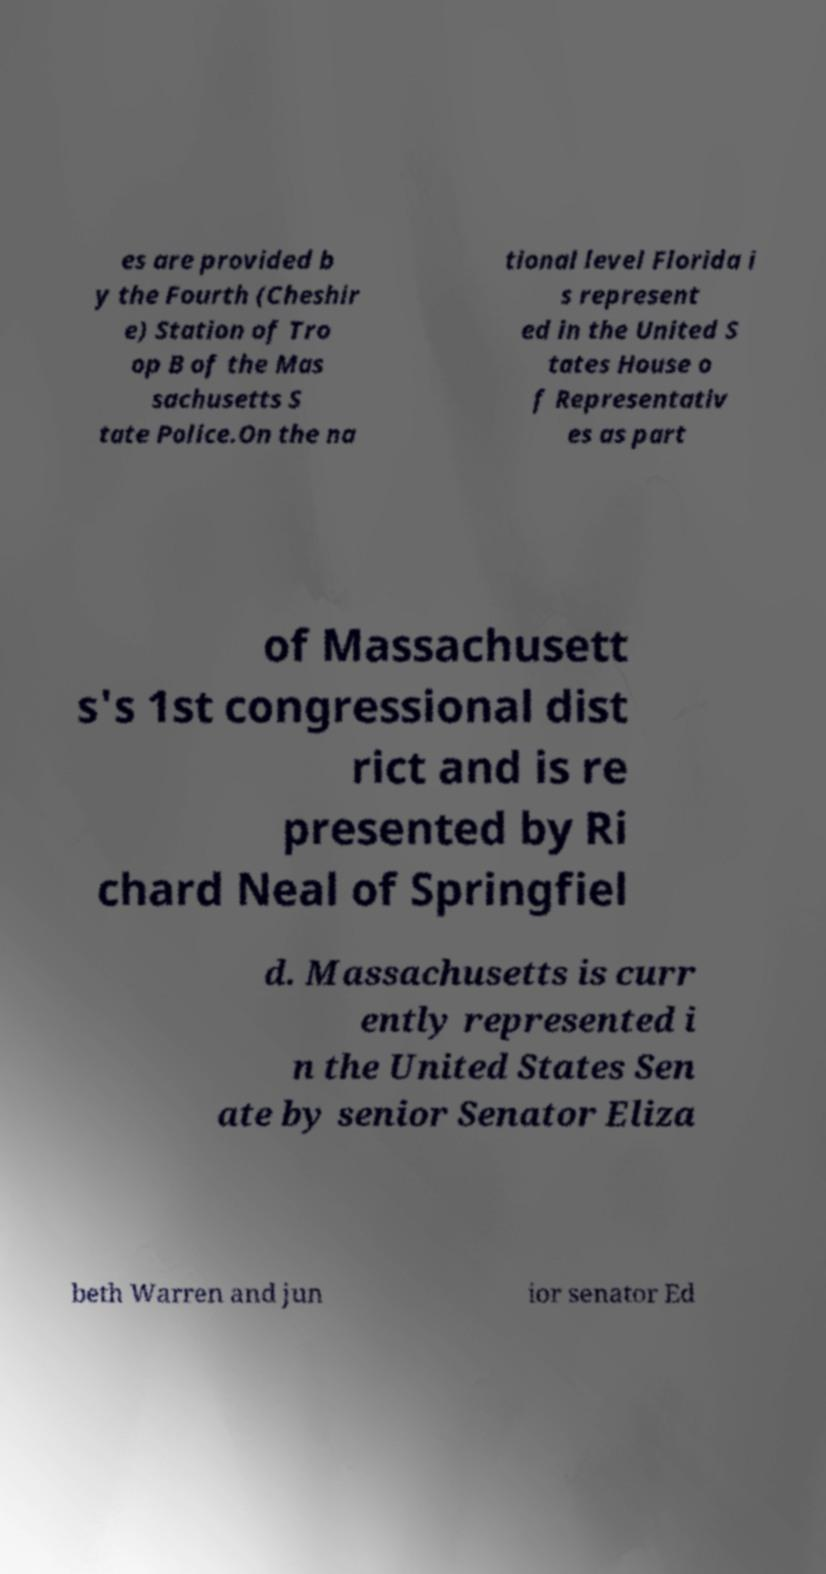For documentation purposes, I need the text within this image transcribed. Could you provide that? es are provided b y the Fourth (Cheshir e) Station of Tro op B of the Mas sachusetts S tate Police.On the na tional level Florida i s represent ed in the United S tates House o f Representativ es as part of Massachusett s's 1st congressional dist rict and is re presented by Ri chard Neal of Springfiel d. Massachusetts is curr ently represented i n the United States Sen ate by senior Senator Eliza beth Warren and jun ior senator Ed 